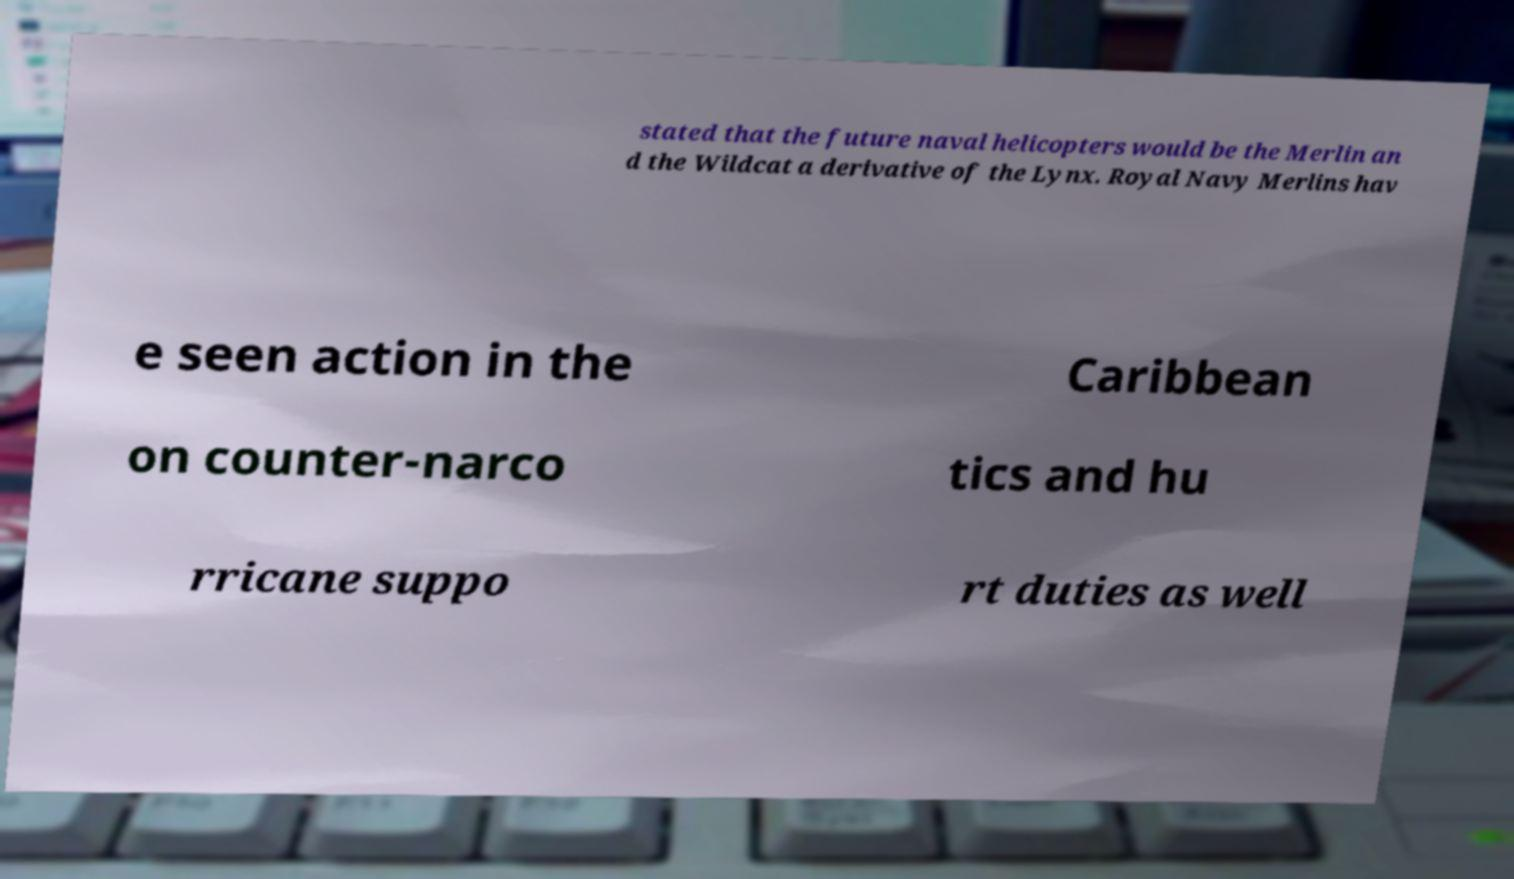For documentation purposes, I need the text within this image transcribed. Could you provide that? stated that the future naval helicopters would be the Merlin an d the Wildcat a derivative of the Lynx. Royal Navy Merlins hav e seen action in the Caribbean on counter-narco tics and hu rricane suppo rt duties as well 